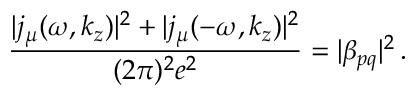<formula> <loc_0><loc_0><loc_500><loc_500>\frac { | j _ { \mu } ( \omega , k _ { z } ) | ^ { 2 } + | j _ { \mu } ( - \omega , k _ { z } ) | ^ { 2 } } { ( 2 \pi ) ^ { 2 } e ^ { 2 } } = | \beta _ { p q } | ^ { 2 } \, .</formula> 